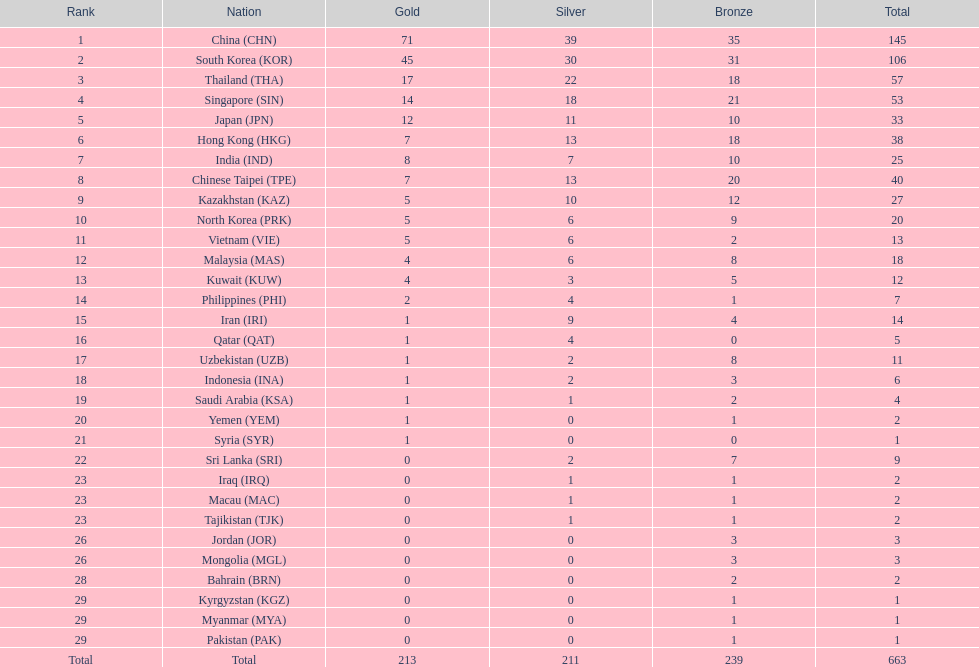What is the distinction between the total number of medals earned by qatar and indonesia? 1. 